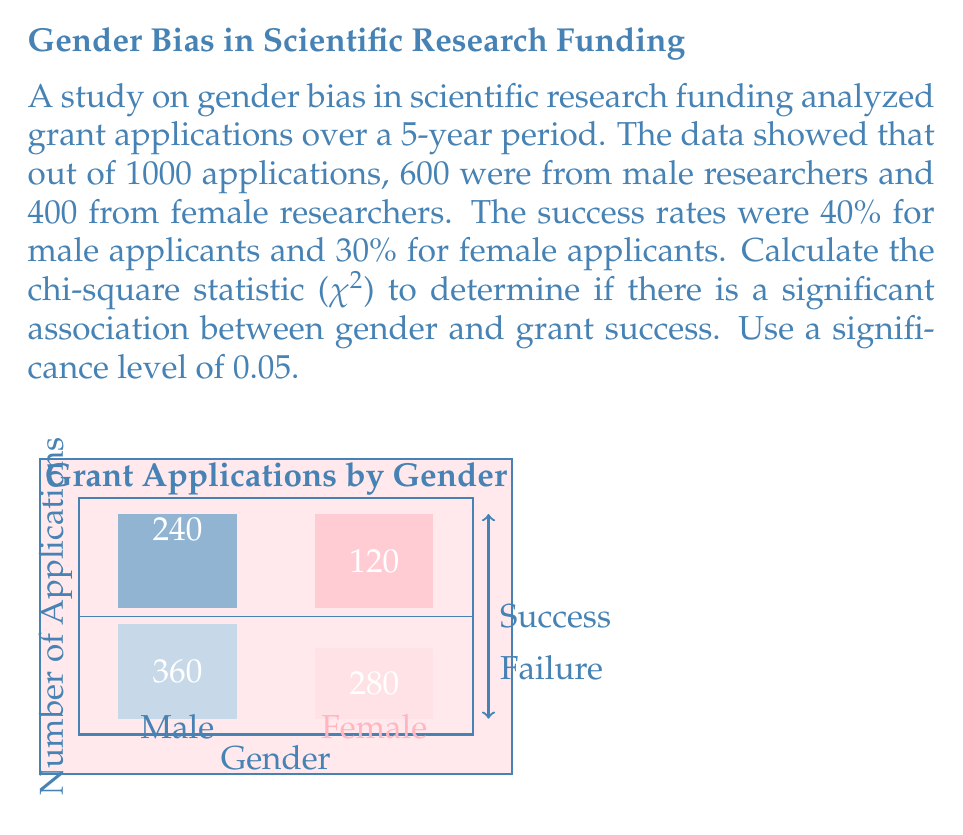Give your solution to this math problem. To calculate the chi-square statistic, we'll follow these steps:

1. Set up the observed frequencies:
   Male success: 240, Male failure: 360
   Female success: 120, Female failure: 280

2. Calculate the expected frequencies:
   $$E = \frac{\text{row total} \times \text{column total}}{\text{grand total}}$$

   Male success: $E_{11} = \frac{600 \times 360}{1000} = 216$
   Male failure: $E_{12} = \frac{600 \times 640}{1000} = 384$
   Female success: $E_{21} = \frac{400 \times 360}{1000} = 144$
   Female failure: $E_{22} = \frac{400 \times 640}{1000} = 256$

3. Calculate the chi-square statistic:
   $$\chi^2 = \sum\frac{(O - E)^2}{E}$$

   $\chi^2 = \frac{(240 - 216)^2}{216} + \frac{(360 - 384)^2}{384} + \frac{(120 - 144)^2}{144} + \frac{(280 - 256)^2}{256}$

   $\chi^2 = \frac{576}{216} + \frac{576}{384} + \frac{576}{144} + \frac{576}{256}$

   $\chi^2 = 2.67 + 1.5 + 4 + 2.25$

   $\chi^2 = 10.42$

4. Determine the degrees of freedom:
   $df = (r - 1)(c - 1) = (2 - 1)(2 - 1) = 1$

5. Compare with the critical value:
   For $df = 1$ and $\alpha = 0.05$, the critical value is 3.841.

Since $10.42 > 3.841$, we reject the null hypothesis of no association between gender and grant success.
Answer: $\chi^2 = 10.42$, significant association exists 